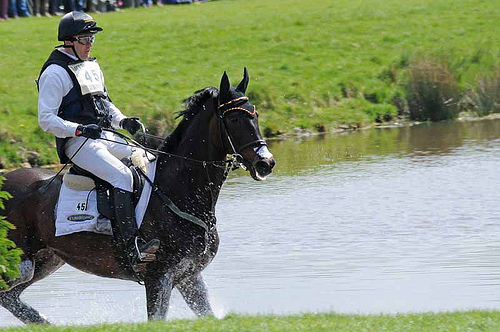Are there both goggles and helmets in the picture? No, there are no goggles in the picture, only a helmet. 